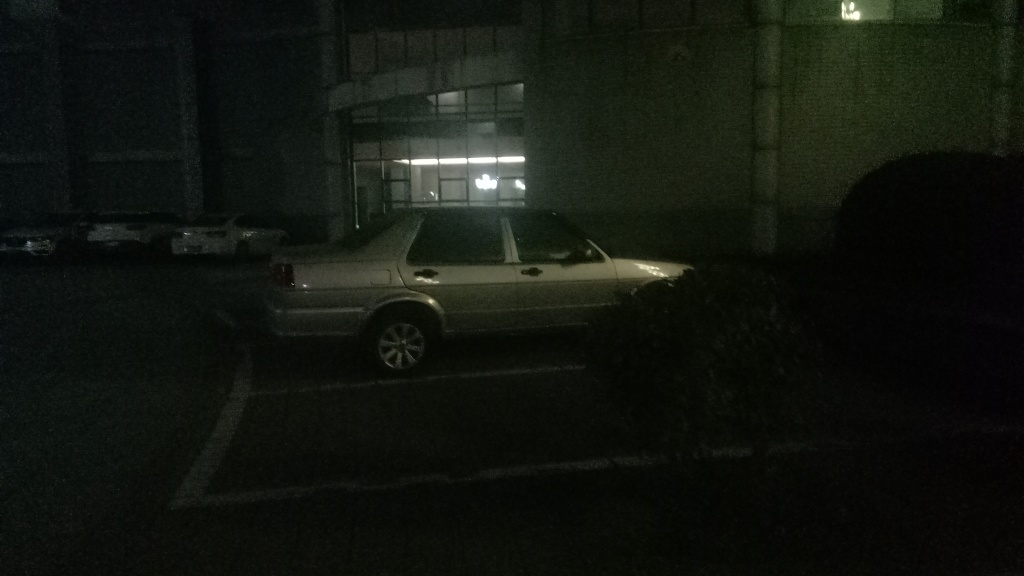Apart from improving lighting, what would enhance the quality of photos like this? To enhance the quality of such photos, one could use a camera with better low-light performance or adjust the camera settings to increase exposure time or ISO. Utilizing a tripod to prevent camera shake during a longer exposure, and possibly capturing the image in RAW format to allow for more post-processing flexibility, would also significantly improve the overall quality. 